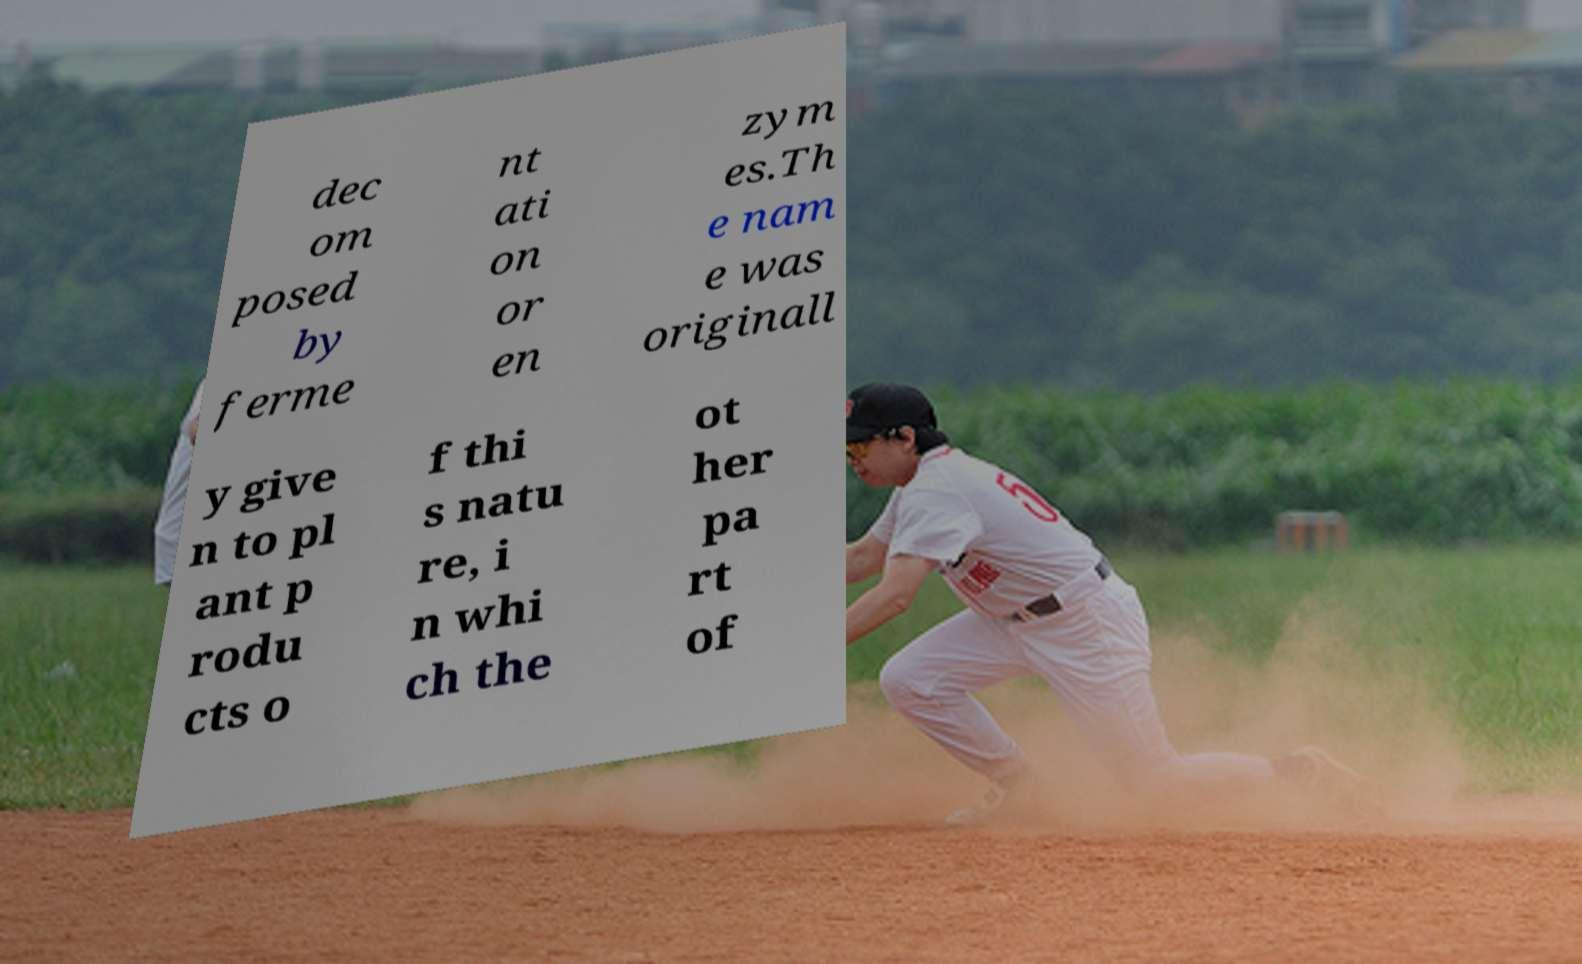Please identify and transcribe the text found in this image. dec om posed by ferme nt ati on or en zym es.Th e nam e was originall y give n to pl ant p rodu cts o f thi s natu re, i n whi ch the ot her pa rt of 